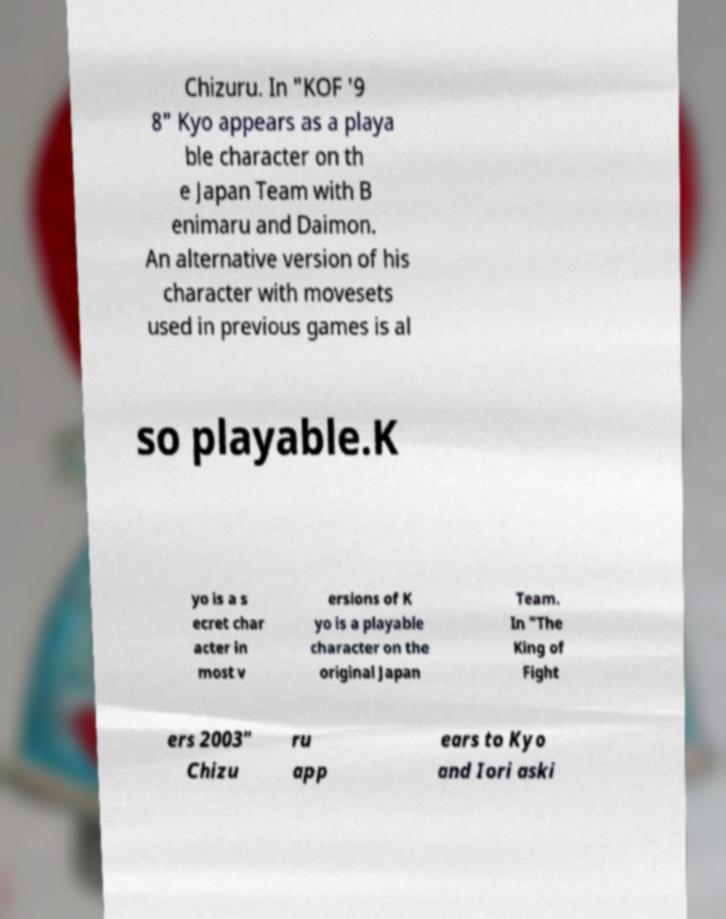For documentation purposes, I need the text within this image transcribed. Could you provide that? Chizuru. In "KOF '9 8" Kyo appears as a playa ble character on th e Japan Team with B enimaru and Daimon. An alternative version of his character with movesets used in previous games is al so playable.K yo is a s ecret char acter in most v ersions of K yo is a playable character on the original Japan Team. In "The King of Fight ers 2003" Chizu ru app ears to Kyo and Iori aski 